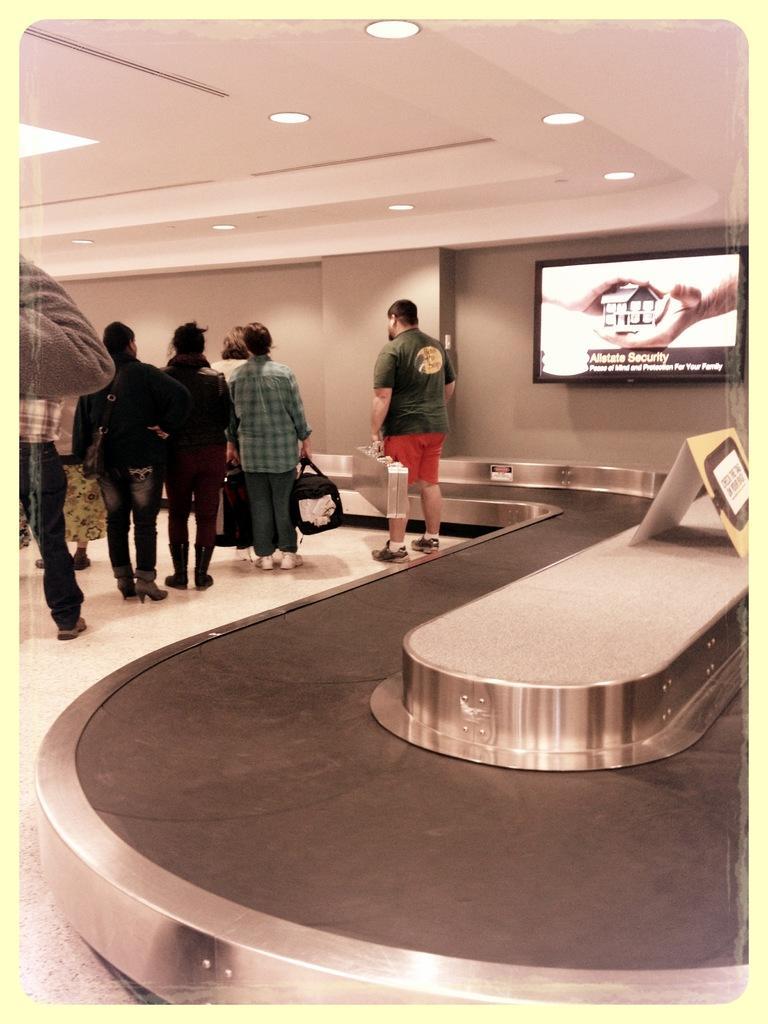Describe this image in one or two sentences. In this image I can see the group of people standing and wearing the different color dresses. To the side there is a board and screen to the wall. I can also see the lights in the top. 